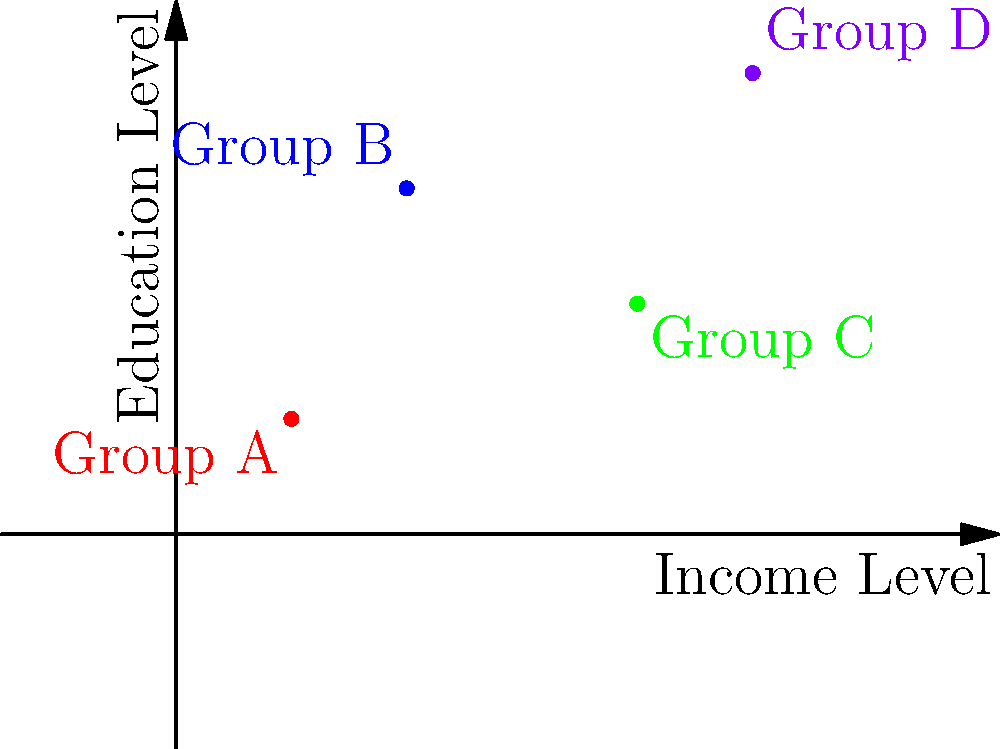In a study on social distance between demographic groups, four groups (A, B, C, and D) are plotted on a scatter plot based on their average income level (x-axis) and education level (y-axis). Calculate the social distance between Group A and Group D using the Euclidean distance formula. Round your answer to two decimal places. To calculate the social distance between Group A and Group D, we'll use the Euclidean distance formula:

$$d = \sqrt{(x_2 - x_1)^2 + (y_2 - y_1)^2}$$

Where:
$(x_1, y_1)$ are the coordinates of Group A (1, 1)
$(x_2, y_2)$ are the coordinates of Group D (5, 4)

Step 1: Identify the coordinates
Group A: (1, 1)
Group D: (5, 4)

Step 2: Apply the formula
$$d = \sqrt{(5 - 1)^2 + (4 - 1)^2}$$

Step 3: Calculate the differences
$$d = \sqrt{4^2 + 3^2}$$

Step 4: Square the differences
$$d = \sqrt{16 + 9}$$

Step 5: Add the squared differences
$$d = \sqrt{25}$$

Step 6: Calculate the square root
$$d = 5$$

The social distance between Group A and Group D is 5 units.
Answer: 5 units 